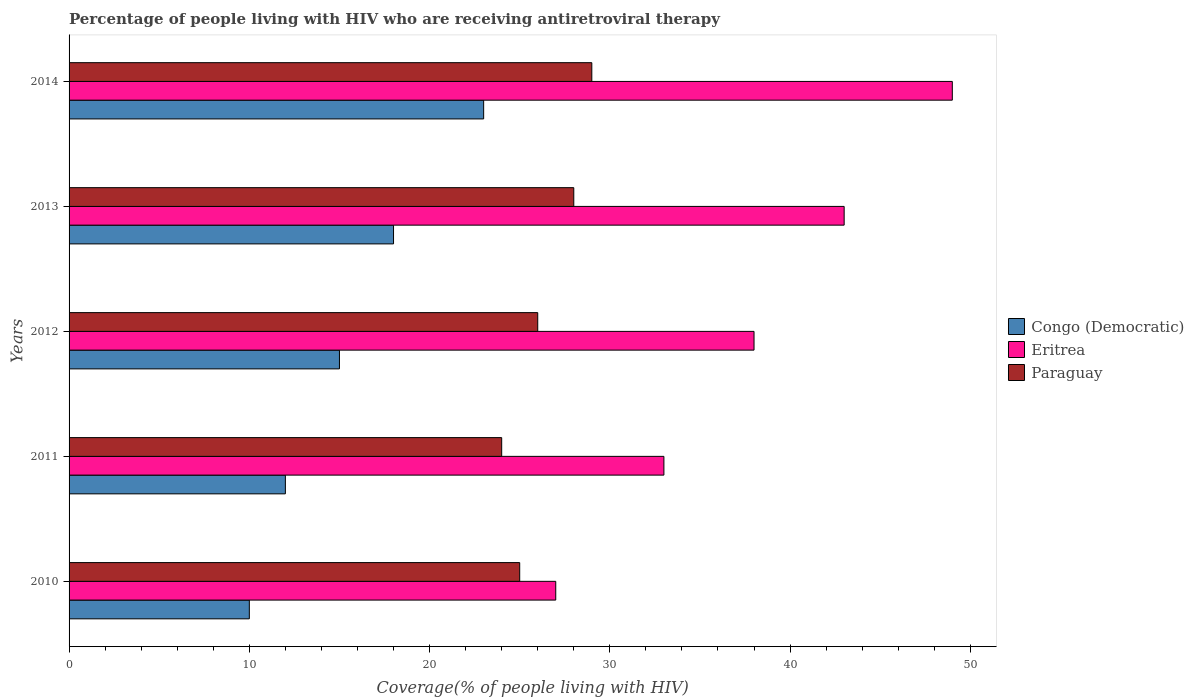How many bars are there on the 4th tick from the top?
Ensure brevity in your answer.  3. What is the label of the 4th group of bars from the top?
Keep it short and to the point. 2011. In how many cases, is the number of bars for a given year not equal to the number of legend labels?
Your answer should be compact. 0. What is the percentage of the HIV infected people who are receiving antiretroviral therapy in Eritrea in 2010?
Keep it short and to the point. 27. Across all years, what is the maximum percentage of the HIV infected people who are receiving antiretroviral therapy in Congo (Democratic)?
Provide a succinct answer. 23. Across all years, what is the minimum percentage of the HIV infected people who are receiving antiretroviral therapy in Congo (Democratic)?
Provide a succinct answer. 10. In which year was the percentage of the HIV infected people who are receiving antiretroviral therapy in Congo (Democratic) maximum?
Offer a terse response. 2014. In which year was the percentage of the HIV infected people who are receiving antiretroviral therapy in Paraguay minimum?
Your response must be concise. 2011. What is the total percentage of the HIV infected people who are receiving antiretroviral therapy in Paraguay in the graph?
Your answer should be very brief. 132. What is the difference between the percentage of the HIV infected people who are receiving antiretroviral therapy in Paraguay in 2012 and that in 2014?
Provide a short and direct response. -3. What is the difference between the percentage of the HIV infected people who are receiving antiretroviral therapy in Paraguay in 2010 and the percentage of the HIV infected people who are receiving antiretroviral therapy in Eritrea in 2012?
Provide a short and direct response. -13. What is the average percentage of the HIV infected people who are receiving antiretroviral therapy in Congo (Democratic) per year?
Offer a very short reply. 15.6. In the year 2012, what is the difference between the percentage of the HIV infected people who are receiving antiretroviral therapy in Eritrea and percentage of the HIV infected people who are receiving antiretroviral therapy in Paraguay?
Your answer should be compact. 12. In how many years, is the percentage of the HIV infected people who are receiving antiretroviral therapy in Paraguay greater than 36 %?
Ensure brevity in your answer.  0. What is the ratio of the percentage of the HIV infected people who are receiving antiretroviral therapy in Paraguay in 2010 to that in 2011?
Offer a terse response. 1.04. Is the percentage of the HIV infected people who are receiving antiretroviral therapy in Congo (Democratic) in 2010 less than that in 2012?
Your answer should be very brief. Yes. Is the difference between the percentage of the HIV infected people who are receiving antiretroviral therapy in Eritrea in 2010 and 2011 greater than the difference between the percentage of the HIV infected people who are receiving antiretroviral therapy in Paraguay in 2010 and 2011?
Ensure brevity in your answer.  No. What is the difference between the highest and the lowest percentage of the HIV infected people who are receiving antiretroviral therapy in Paraguay?
Offer a terse response. 5. Is the sum of the percentage of the HIV infected people who are receiving antiretroviral therapy in Eritrea in 2012 and 2014 greater than the maximum percentage of the HIV infected people who are receiving antiretroviral therapy in Paraguay across all years?
Ensure brevity in your answer.  Yes. What does the 3rd bar from the top in 2012 represents?
Your answer should be very brief. Congo (Democratic). What does the 3rd bar from the bottom in 2013 represents?
Provide a short and direct response. Paraguay. Is it the case that in every year, the sum of the percentage of the HIV infected people who are receiving antiretroviral therapy in Eritrea and percentage of the HIV infected people who are receiving antiretroviral therapy in Congo (Democratic) is greater than the percentage of the HIV infected people who are receiving antiretroviral therapy in Paraguay?
Offer a very short reply. Yes. Are all the bars in the graph horizontal?
Provide a short and direct response. Yes. Does the graph contain any zero values?
Offer a terse response. No. Does the graph contain grids?
Your answer should be compact. No. Where does the legend appear in the graph?
Offer a very short reply. Center right. How are the legend labels stacked?
Your answer should be very brief. Vertical. What is the title of the graph?
Offer a very short reply. Percentage of people living with HIV who are receiving antiretroviral therapy. Does "Italy" appear as one of the legend labels in the graph?
Keep it short and to the point. No. What is the label or title of the X-axis?
Your answer should be compact. Coverage(% of people living with HIV). What is the label or title of the Y-axis?
Ensure brevity in your answer.  Years. What is the Coverage(% of people living with HIV) of Congo (Democratic) in 2010?
Offer a terse response. 10. What is the Coverage(% of people living with HIV) of Paraguay in 2010?
Your answer should be very brief. 25. What is the Coverage(% of people living with HIV) in Congo (Democratic) in 2011?
Your answer should be very brief. 12. What is the Coverage(% of people living with HIV) of Eritrea in 2011?
Keep it short and to the point. 33. What is the Coverage(% of people living with HIV) of Eritrea in 2012?
Provide a short and direct response. 38. What is the Coverage(% of people living with HIV) of Eritrea in 2013?
Your answer should be very brief. 43. What is the Coverage(% of people living with HIV) of Paraguay in 2014?
Provide a succinct answer. 29. Across all years, what is the minimum Coverage(% of people living with HIV) of Congo (Democratic)?
Your answer should be very brief. 10. Across all years, what is the minimum Coverage(% of people living with HIV) in Eritrea?
Offer a terse response. 27. Across all years, what is the minimum Coverage(% of people living with HIV) in Paraguay?
Give a very brief answer. 24. What is the total Coverage(% of people living with HIV) of Eritrea in the graph?
Your answer should be very brief. 190. What is the total Coverage(% of people living with HIV) in Paraguay in the graph?
Provide a succinct answer. 132. What is the difference between the Coverage(% of people living with HIV) in Paraguay in 2010 and that in 2011?
Your response must be concise. 1. What is the difference between the Coverage(% of people living with HIV) of Paraguay in 2010 and that in 2012?
Make the answer very short. -1. What is the difference between the Coverage(% of people living with HIV) in Congo (Democratic) in 2010 and that in 2013?
Provide a short and direct response. -8. What is the difference between the Coverage(% of people living with HIV) in Eritrea in 2010 and that in 2013?
Make the answer very short. -16. What is the difference between the Coverage(% of people living with HIV) of Paraguay in 2010 and that in 2013?
Ensure brevity in your answer.  -3. What is the difference between the Coverage(% of people living with HIV) of Congo (Democratic) in 2010 and that in 2014?
Make the answer very short. -13. What is the difference between the Coverage(% of people living with HIV) of Eritrea in 2010 and that in 2014?
Ensure brevity in your answer.  -22. What is the difference between the Coverage(% of people living with HIV) of Paraguay in 2011 and that in 2013?
Make the answer very short. -4. What is the difference between the Coverage(% of people living with HIV) in Congo (Democratic) in 2011 and that in 2014?
Offer a terse response. -11. What is the difference between the Coverage(% of people living with HIV) of Eritrea in 2011 and that in 2014?
Offer a terse response. -16. What is the difference between the Coverage(% of people living with HIV) of Paraguay in 2011 and that in 2014?
Keep it short and to the point. -5. What is the difference between the Coverage(% of people living with HIV) in Paraguay in 2012 and that in 2013?
Make the answer very short. -2. What is the difference between the Coverage(% of people living with HIV) of Eritrea in 2012 and that in 2014?
Provide a short and direct response. -11. What is the difference between the Coverage(% of people living with HIV) of Paraguay in 2012 and that in 2014?
Provide a short and direct response. -3. What is the difference between the Coverage(% of people living with HIV) of Congo (Democratic) in 2013 and that in 2014?
Keep it short and to the point. -5. What is the difference between the Coverage(% of people living with HIV) of Congo (Democratic) in 2010 and the Coverage(% of people living with HIV) of Eritrea in 2011?
Make the answer very short. -23. What is the difference between the Coverage(% of people living with HIV) in Eritrea in 2010 and the Coverage(% of people living with HIV) in Paraguay in 2011?
Make the answer very short. 3. What is the difference between the Coverage(% of people living with HIV) of Congo (Democratic) in 2010 and the Coverage(% of people living with HIV) of Eritrea in 2013?
Offer a terse response. -33. What is the difference between the Coverage(% of people living with HIV) of Congo (Democratic) in 2010 and the Coverage(% of people living with HIV) of Eritrea in 2014?
Give a very brief answer. -39. What is the difference between the Coverage(% of people living with HIV) of Congo (Democratic) in 2010 and the Coverage(% of people living with HIV) of Paraguay in 2014?
Provide a short and direct response. -19. What is the difference between the Coverage(% of people living with HIV) of Congo (Democratic) in 2011 and the Coverage(% of people living with HIV) of Paraguay in 2012?
Offer a terse response. -14. What is the difference between the Coverage(% of people living with HIV) in Congo (Democratic) in 2011 and the Coverage(% of people living with HIV) in Eritrea in 2013?
Make the answer very short. -31. What is the difference between the Coverage(% of people living with HIV) in Eritrea in 2011 and the Coverage(% of people living with HIV) in Paraguay in 2013?
Offer a very short reply. 5. What is the difference between the Coverage(% of people living with HIV) in Congo (Democratic) in 2011 and the Coverage(% of people living with HIV) in Eritrea in 2014?
Offer a terse response. -37. What is the difference between the Coverage(% of people living with HIV) in Congo (Democratic) in 2011 and the Coverage(% of people living with HIV) in Paraguay in 2014?
Provide a succinct answer. -17. What is the difference between the Coverage(% of people living with HIV) in Eritrea in 2012 and the Coverage(% of people living with HIV) in Paraguay in 2013?
Give a very brief answer. 10. What is the difference between the Coverage(% of people living with HIV) of Congo (Democratic) in 2012 and the Coverage(% of people living with HIV) of Eritrea in 2014?
Your answer should be compact. -34. What is the difference between the Coverage(% of people living with HIV) of Eritrea in 2012 and the Coverage(% of people living with HIV) of Paraguay in 2014?
Give a very brief answer. 9. What is the difference between the Coverage(% of people living with HIV) of Congo (Democratic) in 2013 and the Coverage(% of people living with HIV) of Eritrea in 2014?
Your answer should be compact. -31. What is the difference between the Coverage(% of people living with HIV) in Eritrea in 2013 and the Coverage(% of people living with HIV) in Paraguay in 2014?
Your response must be concise. 14. What is the average Coverage(% of people living with HIV) in Paraguay per year?
Your response must be concise. 26.4. In the year 2010, what is the difference between the Coverage(% of people living with HIV) in Congo (Democratic) and Coverage(% of people living with HIV) in Eritrea?
Your answer should be very brief. -17. In the year 2011, what is the difference between the Coverage(% of people living with HIV) in Eritrea and Coverage(% of people living with HIV) in Paraguay?
Your answer should be very brief. 9. In the year 2012, what is the difference between the Coverage(% of people living with HIV) in Eritrea and Coverage(% of people living with HIV) in Paraguay?
Your answer should be very brief. 12. In the year 2013, what is the difference between the Coverage(% of people living with HIV) of Congo (Democratic) and Coverage(% of people living with HIV) of Eritrea?
Make the answer very short. -25. In the year 2013, what is the difference between the Coverage(% of people living with HIV) of Eritrea and Coverage(% of people living with HIV) of Paraguay?
Offer a very short reply. 15. In the year 2014, what is the difference between the Coverage(% of people living with HIV) in Congo (Democratic) and Coverage(% of people living with HIV) in Eritrea?
Ensure brevity in your answer.  -26. What is the ratio of the Coverage(% of people living with HIV) in Eritrea in 2010 to that in 2011?
Your response must be concise. 0.82. What is the ratio of the Coverage(% of people living with HIV) of Paraguay in 2010 to that in 2011?
Give a very brief answer. 1.04. What is the ratio of the Coverage(% of people living with HIV) in Congo (Democratic) in 2010 to that in 2012?
Your response must be concise. 0.67. What is the ratio of the Coverage(% of people living with HIV) in Eritrea in 2010 to that in 2012?
Your answer should be compact. 0.71. What is the ratio of the Coverage(% of people living with HIV) of Paraguay in 2010 to that in 2012?
Your answer should be very brief. 0.96. What is the ratio of the Coverage(% of people living with HIV) of Congo (Democratic) in 2010 to that in 2013?
Give a very brief answer. 0.56. What is the ratio of the Coverage(% of people living with HIV) of Eritrea in 2010 to that in 2013?
Your answer should be very brief. 0.63. What is the ratio of the Coverage(% of people living with HIV) in Paraguay in 2010 to that in 2013?
Provide a short and direct response. 0.89. What is the ratio of the Coverage(% of people living with HIV) in Congo (Democratic) in 2010 to that in 2014?
Your answer should be compact. 0.43. What is the ratio of the Coverage(% of people living with HIV) in Eritrea in 2010 to that in 2014?
Offer a terse response. 0.55. What is the ratio of the Coverage(% of people living with HIV) in Paraguay in 2010 to that in 2014?
Keep it short and to the point. 0.86. What is the ratio of the Coverage(% of people living with HIV) of Eritrea in 2011 to that in 2012?
Provide a succinct answer. 0.87. What is the ratio of the Coverage(% of people living with HIV) of Paraguay in 2011 to that in 2012?
Provide a succinct answer. 0.92. What is the ratio of the Coverage(% of people living with HIV) in Eritrea in 2011 to that in 2013?
Your answer should be very brief. 0.77. What is the ratio of the Coverage(% of people living with HIV) of Paraguay in 2011 to that in 2013?
Make the answer very short. 0.86. What is the ratio of the Coverage(% of people living with HIV) of Congo (Democratic) in 2011 to that in 2014?
Ensure brevity in your answer.  0.52. What is the ratio of the Coverage(% of people living with HIV) of Eritrea in 2011 to that in 2014?
Offer a very short reply. 0.67. What is the ratio of the Coverage(% of people living with HIV) of Paraguay in 2011 to that in 2014?
Give a very brief answer. 0.83. What is the ratio of the Coverage(% of people living with HIV) in Congo (Democratic) in 2012 to that in 2013?
Provide a short and direct response. 0.83. What is the ratio of the Coverage(% of people living with HIV) in Eritrea in 2012 to that in 2013?
Provide a succinct answer. 0.88. What is the ratio of the Coverage(% of people living with HIV) of Congo (Democratic) in 2012 to that in 2014?
Offer a terse response. 0.65. What is the ratio of the Coverage(% of people living with HIV) of Eritrea in 2012 to that in 2014?
Ensure brevity in your answer.  0.78. What is the ratio of the Coverage(% of people living with HIV) in Paraguay in 2012 to that in 2014?
Your answer should be very brief. 0.9. What is the ratio of the Coverage(% of people living with HIV) in Congo (Democratic) in 2013 to that in 2014?
Provide a short and direct response. 0.78. What is the ratio of the Coverage(% of people living with HIV) of Eritrea in 2013 to that in 2014?
Offer a terse response. 0.88. What is the ratio of the Coverage(% of people living with HIV) of Paraguay in 2013 to that in 2014?
Offer a very short reply. 0.97. What is the difference between the highest and the second highest Coverage(% of people living with HIV) in Paraguay?
Offer a terse response. 1. What is the difference between the highest and the lowest Coverage(% of people living with HIV) of Congo (Democratic)?
Your answer should be very brief. 13. What is the difference between the highest and the lowest Coverage(% of people living with HIV) in Paraguay?
Your answer should be compact. 5. 